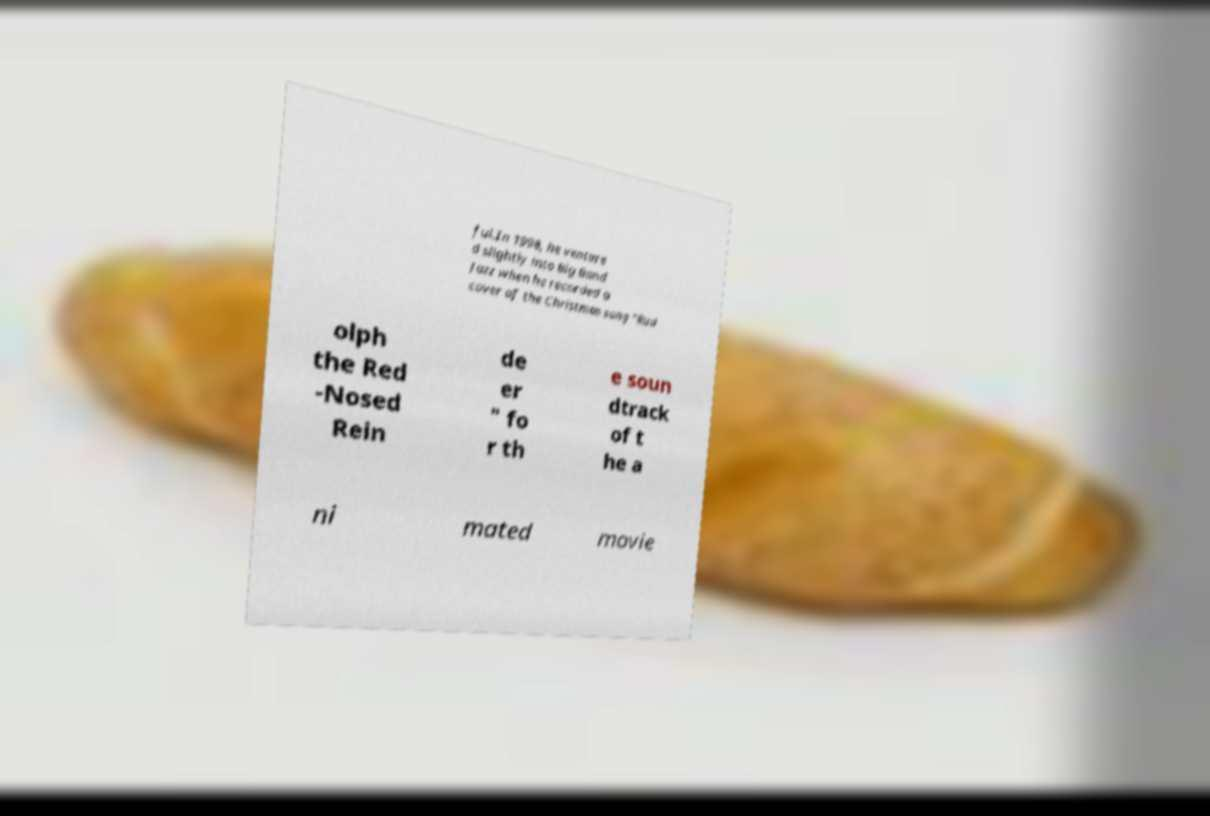There's text embedded in this image that I need extracted. Can you transcribe it verbatim? ful.In 1998, he venture d slightly into Big Band Jazz when he recorded a cover of the Christmas song "Rud olph the Red -Nosed Rein de er " fo r th e soun dtrack of t he a ni mated movie 